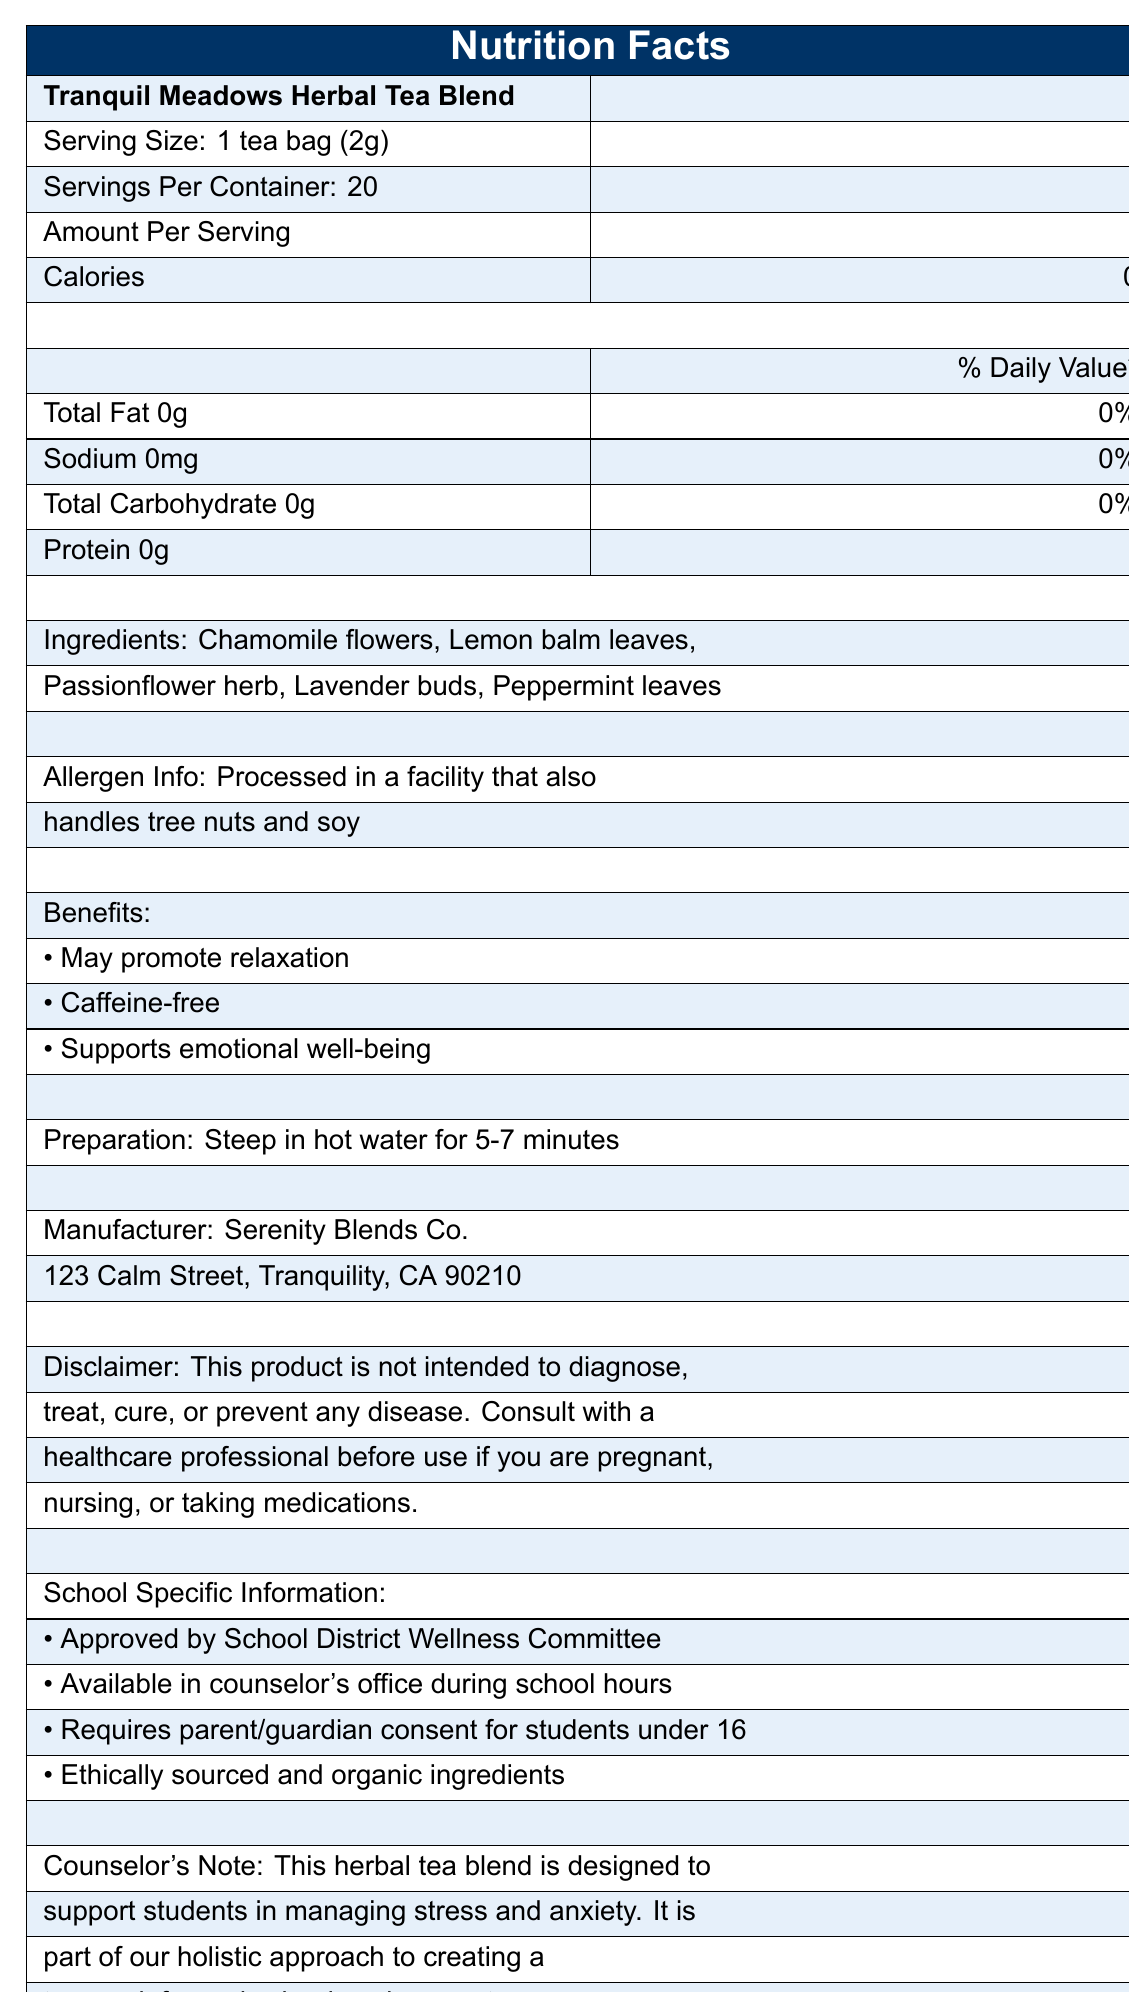what is the product name? The product name is stated at the beginning of the document as "Tranquil Meadows Herbal Tea Blend".
Answer: Tranquil Meadows Herbal Tea Blend what is the serving size of the tea? The serving size is listed in the document as "1 tea bag (2g)".
Answer: 1 tea bag (2g) how many servings are in one container? The document specifies that there are 20 servings per container.
Answer: 20 is this tea caffeine-free? One of the benefits listed in the document is "Caffeine-free".
Answer: Yes what are the ingredients in the tea blend? The document lists the ingredients as "Chamomile flowers, Lemon balm leaves, Passionflower herb, Lavender buds, Peppermint leaves".
Answer: Chamomile flowers, Lemon balm leaves, Passionflower herb, Lavender buds, Peppermint leaves how many calories are in one serving of the tea? The document states that there are 0 calories per serving.
Answer: 0 calories what is the percentage of daily value for sodium in the tea? The document shows that the daily value percentage for sodium is 0%.
Answer: 0% multiple-choice: where is the manufacturer located? A. 123 Calm Street, Tranquility, CA 90210 B. 456 Serenity Lane, Peaceville, NY 10010 C. 789 Harmony Road, Relaxation, WA 60440 The document states the manufacturer's address as "123 Calm Street, Tranquility, CA 90210".
Answer: A multiple-choice: which of the following is not an ingredient in the tea? I. Chamomile flowers II. Ginger root III. Lavender buds IV. Peppermint leaves The document lists the ingredients as Chamomile flowers, Lemon balm leaves, Passionflower herb, Lavender buds, and Peppermint leaves. Ginger root is not listed as an ingredient.
Answer: II true/false: the tea blend is processed in a facility that handles peanuts. The document states that the allergen info specifies tree nuts and soy, not peanuts.
Answer: False yes/no: does this product require parent/guardian consent for students under 16 to access it? The document clearly mentions that it "requires parent/guardian consent for students under 16".
Answer: Yes describe the main idea of the document. The document gives comprehensive insights into the herbal tea blend, focusing on its nutritional information, benefits specific to students, preparation, sourcing, and school-related usage guidelines designed to support a trauma-informed environment.
Answer: The document is a Nutrition Facts Label for "Tranquil Meadows Herbal Tea Blend" that provides detailed information about the tea's nutritional content, ingredients, benefits, preparation instructions, manufacturer details, allergen info, and school-specific details. The product is caffeine-free, promotes relaxation, and supports emotional well-being. It is approved by the School District Wellness Committee and available in the counselor's office with certain consent requirements. are there any sugars in one serving of the tea? The document does not list any sugars under the nutritional information.
Answer: No what benefits does the tea provide? The document lists these specific benefits under the benefits section.
Answer: May promote relaxation, Caffeine-free, Supports emotional well-being who should be consulted before using this tea if someone is pregnant, nursing, or taking medications? The document includes a disclaimer advising consultation with a healthcare professional if pregnant, nursing, or taking medications.
Answer: A healthcare professional how should the tea be prepared? The preparation instructions specify to steep the tea in hot water for 5-7 minutes.
Answer: Steep in hot water for 5-7 minutes what is the weight of one tea bag? The serving size is given as "1 tea bag (2g)".
Answer: 2g are there any allergens in the tea itself? The document states that the tea is processed in a facility that handles tree nuts and soy, but it does not specify whether these allergens are present in the tea itself.
Answer: Cannot be determined 